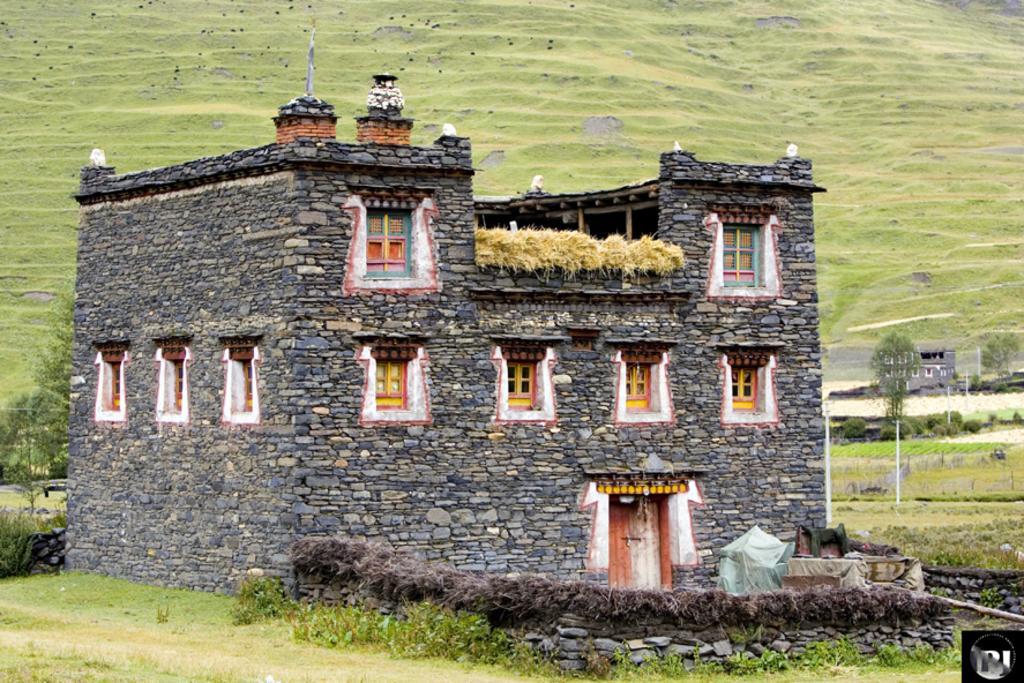Describe this image in one or two sentences. In this image I can see a building made up of rocks. I can see trees on both sides of the image. I can see another house behind. I can see the green open garden at the top of the image. 